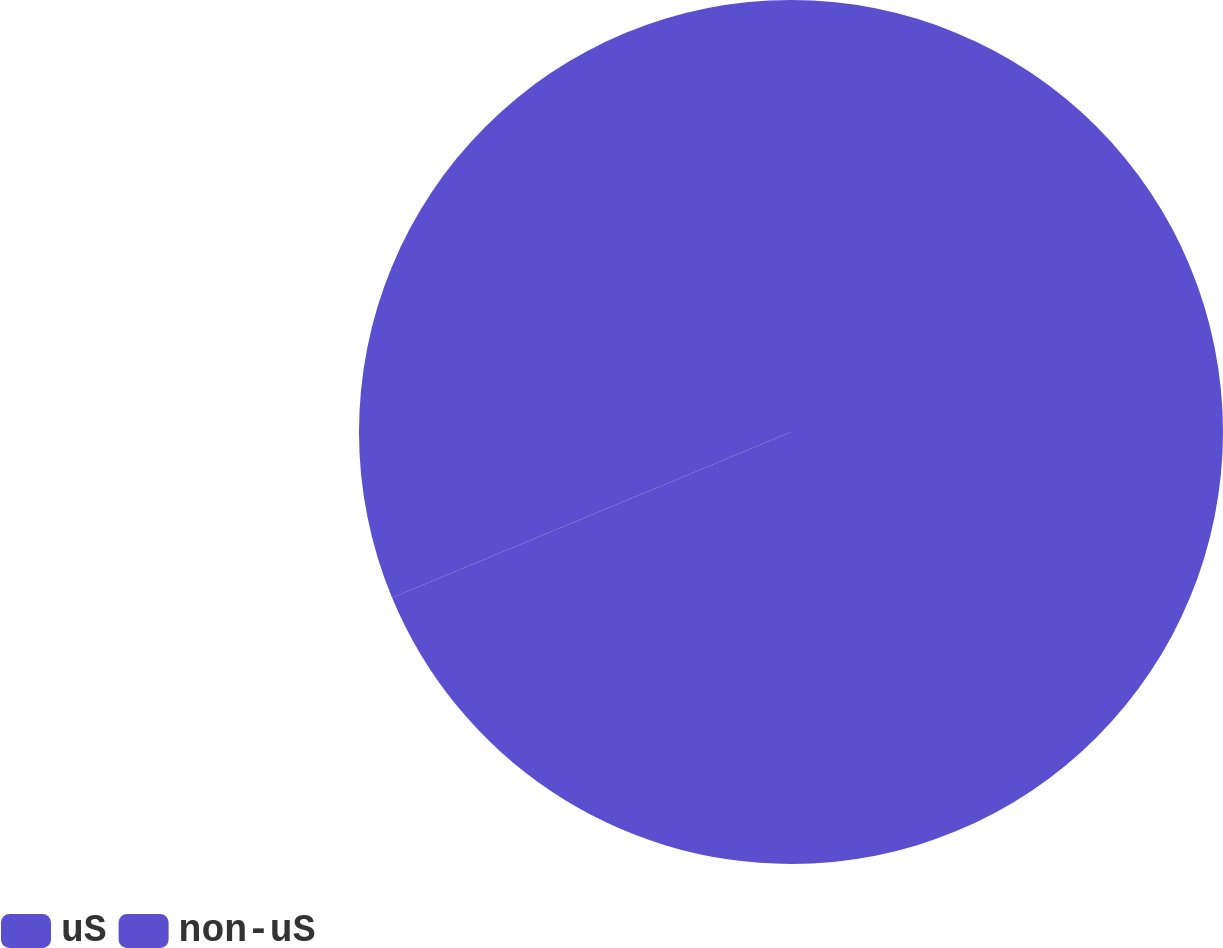Convert chart to OTSL. <chart><loc_0><loc_0><loc_500><loc_500><pie_chart><fcel>uS<fcel>non-uS<nl><fcel>68.73%<fcel>31.27%<nl></chart> 